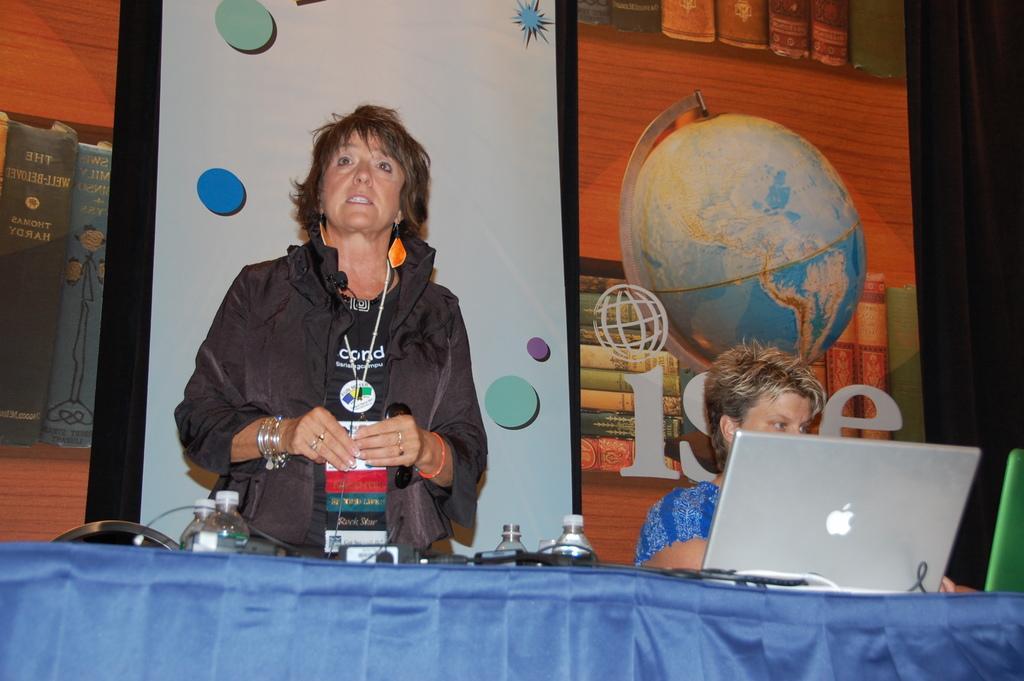Describe this image in one or two sentences. In this image we can see a woman standing beside a table containing some bottles, wires and a laptop on it. On the right side we can see a woman sitting in front of a laptop typing on the keypad. 